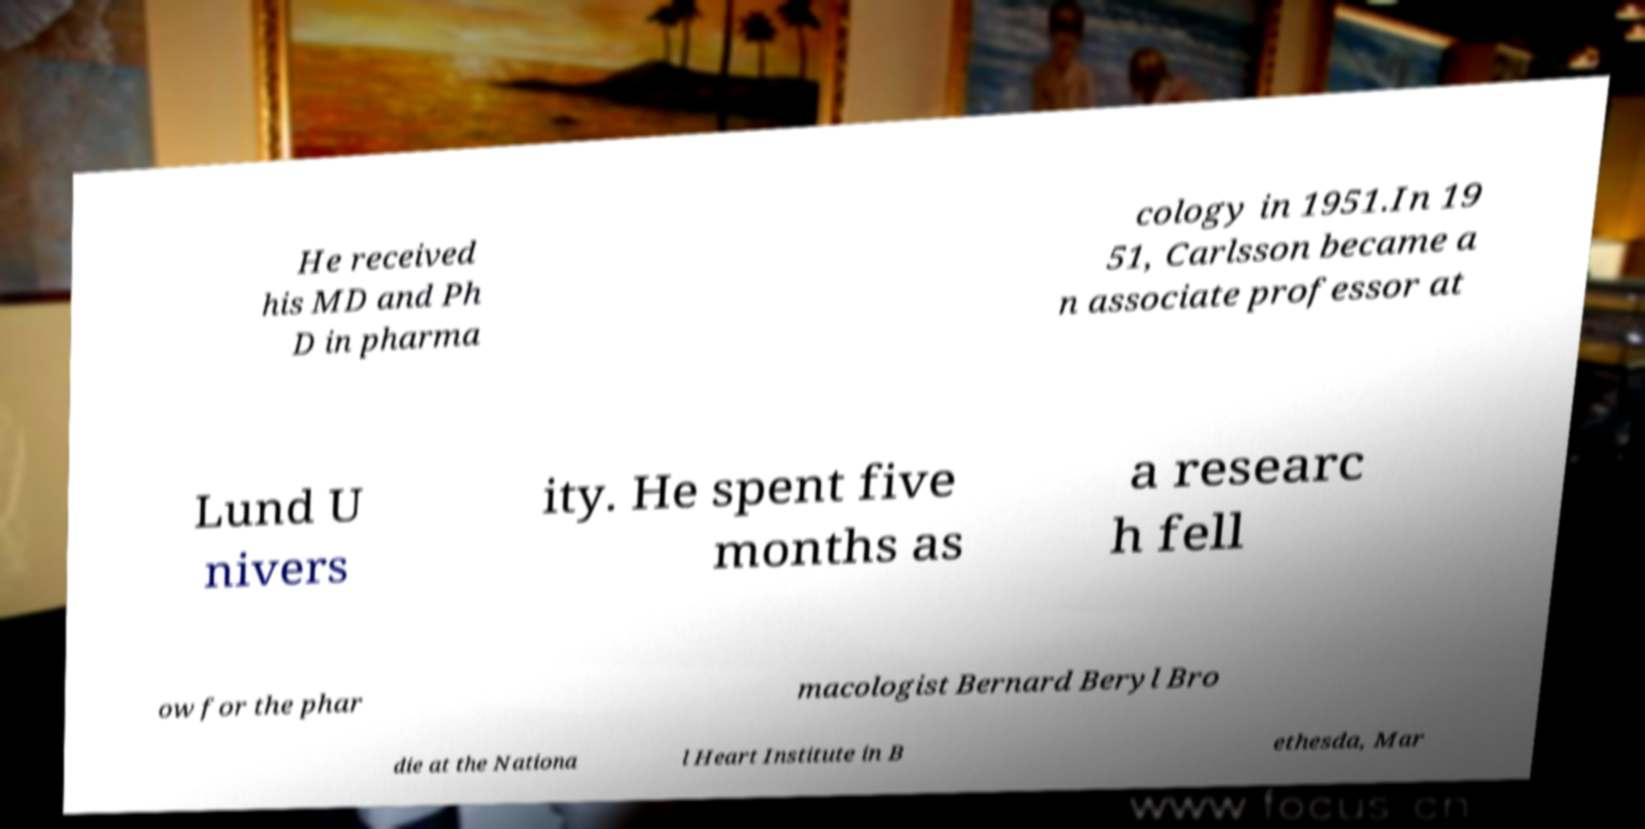Could you assist in decoding the text presented in this image and type it out clearly? He received his MD and Ph D in pharma cology in 1951.In 19 51, Carlsson became a n associate professor at Lund U nivers ity. He spent five months as a researc h fell ow for the phar macologist Bernard Beryl Bro die at the Nationa l Heart Institute in B ethesda, Mar 